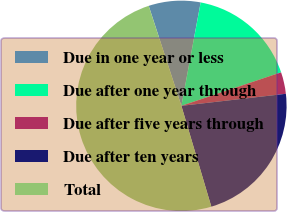<chart> <loc_0><loc_0><loc_500><loc_500><pie_chart><fcel>Due in one year or less<fcel>Due after one year through<fcel>Due after five years through<fcel>Due after ten years<fcel>Total<nl><fcel>7.96%<fcel>16.91%<fcel>3.33%<fcel>22.23%<fcel>49.57%<nl></chart> 